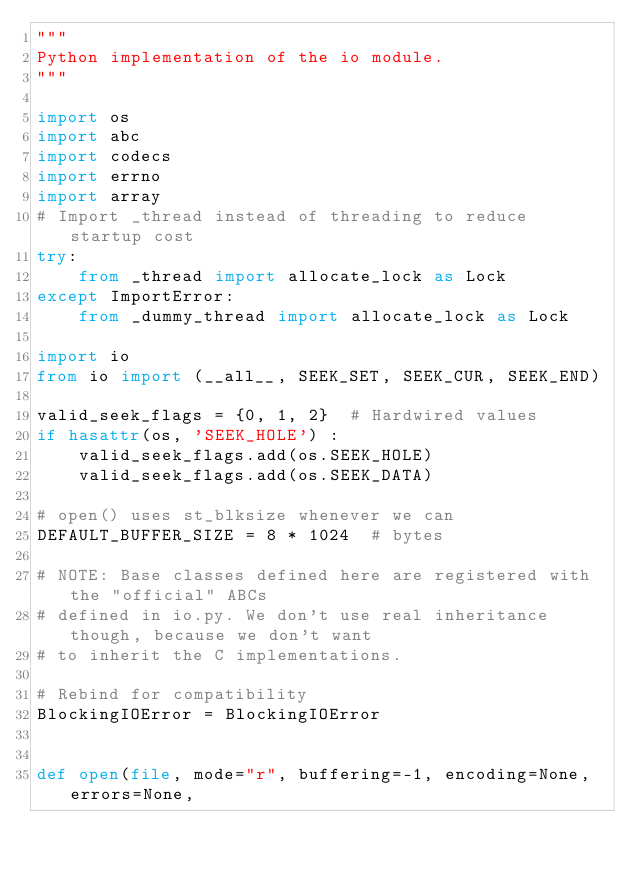Convert code to text. <code><loc_0><loc_0><loc_500><loc_500><_Python_>"""
Python implementation of the io module.
"""

import os
import abc
import codecs
import errno
import array
# Import _thread instead of threading to reduce startup cost
try:
    from _thread import allocate_lock as Lock
except ImportError:
    from _dummy_thread import allocate_lock as Lock

import io
from io import (__all__, SEEK_SET, SEEK_CUR, SEEK_END)

valid_seek_flags = {0, 1, 2}  # Hardwired values
if hasattr(os, 'SEEK_HOLE') :
    valid_seek_flags.add(os.SEEK_HOLE)
    valid_seek_flags.add(os.SEEK_DATA)

# open() uses st_blksize whenever we can
DEFAULT_BUFFER_SIZE = 8 * 1024  # bytes

# NOTE: Base classes defined here are registered with the "official" ABCs
# defined in io.py. We don't use real inheritance though, because we don't want
# to inherit the C implementations.

# Rebind for compatibility
BlockingIOError = BlockingIOError


def open(file, mode="r", buffering=-1, encoding=None, errors=None,</code> 